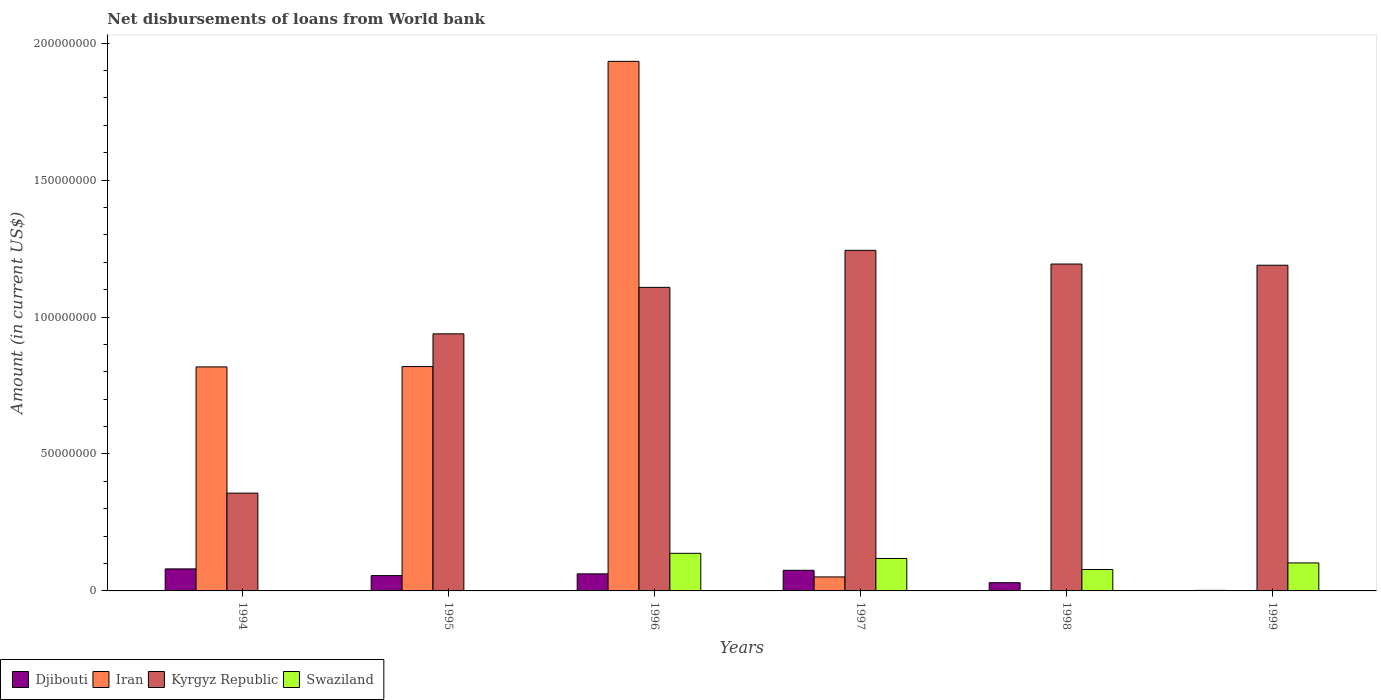How many groups of bars are there?
Ensure brevity in your answer.  6. Are the number of bars on each tick of the X-axis equal?
Your answer should be compact. No. How many bars are there on the 3rd tick from the left?
Provide a short and direct response. 4. What is the label of the 1st group of bars from the left?
Your response must be concise. 1994. What is the amount of loan disbursed from World Bank in Djibouti in 1996?
Your response must be concise. 6.23e+06. Across all years, what is the maximum amount of loan disbursed from World Bank in Swaziland?
Your response must be concise. 1.37e+07. Across all years, what is the minimum amount of loan disbursed from World Bank in Djibouti?
Give a very brief answer. 1.97e+05. In which year was the amount of loan disbursed from World Bank in Kyrgyz Republic maximum?
Provide a short and direct response. 1997. What is the total amount of loan disbursed from World Bank in Kyrgyz Republic in the graph?
Keep it short and to the point. 6.03e+08. What is the difference between the amount of loan disbursed from World Bank in Djibouti in 1995 and that in 1999?
Provide a succinct answer. 5.39e+06. What is the difference between the amount of loan disbursed from World Bank in Iran in 1994 and the amount of loan disbursed from World Bank in Djibouti in 1995?
Provide a short and direct response. 7.62e+07. What is the average amount of loan disbursed from World Bank in Kyrgyz Republic per year?
Keep it short and to the point. 1.01e+08. In the year 1995, what is the difference between the amount of loan disbursed from World Bank in Kyrgyz Republic and amount of loan disbursed from World Bank in Iran?
Ensure brevity in your answer.  1.20e+07. What is the ratio of the amount of loan disbursed from World Bank in Djibouti in 1995 to that in 1997?
Your response must be concise. 0.74. What is the difference between the highest and the second highest amount of loan disbursed from World Bank in Iran?
Your answer should be compact. 1.11e+08. What is the difference between the highest and the lowest amount of loan disbursed from World Bank in Swaziland?
Ensure brevity in your answer.  1.37e+07. In how many years, is the amount of loan disbursed from World Bank in Swaziland greater than the average amount of loan disbursed from World Bank in Swaziland taken over all years?
Keep it short and to the point. 4. Are all the bars in the graph horizontal?
Make the answer very short. No. Does the graph contain any zero values?
Provide a short and direct response. Yes. Where does the legend appear in the graph?
Give a very brief answer. Bottom left. How are the legend labels stacked?
Your answer should be very brief. Horizontal. What is the title of the graph?
Provide a short and direct response. Net disbursements of loans from World bank. Does "Italy" appear as one of the legend labels in the graph?
Give a very brief answer. No. What is the label or title of the X-axis?
Make the answer very short. Years. What is the label or title of the Y-axis?
Offer a terse response. Amount (in current US$). What is the Amount (in current US$) in Djibouti in 1994?
Make the answer very short. 8.04e+06. What is the Amount (in current US$) of Iran in 1994?
Give a very brief answer. 8.18e+07. What is the Amount (in current US$) in Kyrgyz Republic in 1994?
Ensure brevity in your answer.  3.57e+07. What is the Amount (in current US$) in Swaziland in 1994?
Your answer should be compact. 1.38e+05. What is the Amount (in current US$) in Djibouti in 1995?
Provide a short and direct response. 5.59e+06. What is the Amount (in current US$) of Iran in 1995?
Provide a succinct answer. 8.19e+07. What is the Amount (in current US$) in Kyrgyz Republic in 1995?
Offer a very short reply. 9.39e+07. What is the Amount (in current US$) of Swaziland in 1995?
Offer a very short reply. 0. What is the Amount (in current US$) of Djibouti in 1996?
Offer a very short reply. 6.23e+06. What is the Amount (in current US$) in Iran in 1996?
Provide a short and direct response. 1.93e+08. What is the Amount (in current US$) of Kyrgyz Republic in 1996?
Make the answer very short. 1.11e+08. What is the Amount (in current US$) in Swaziland in 1996?
Provide a succinct answer. 1.37e+07. What is the Amount (in current US$) in Djibouti in 1997?
Keep it short and to the point. 7.53e+06. What is the Amount (in current US$) in Iran in 1997?
Keep it short and to the point. 5.11e+06. What is the Amount (in current US$) of Kyrgyz Republic in 1997?
Give a very brief answer. 1.24e+08. What is the Amount (in current US$) in Swaziland in 1997?
Offer a terse response. 1.18e+07. What is the Amount (in current US$) of Djibouti in 1998?
Your answer should be compact. 3.00e+06. What is the Amount (in current US$) of Kyrgyz Republic in 1998?
Your answer should be very brief. 1.19e+08. What is the Amount (in current US$) in Swaziland in 1998?
Keep it short and to the point. 7.82e+06. What is the Amount (in current US$) in Djibouti in 1999?
Keep it short and to the point. 1.97e+05. What is the Amount (in current US$) in Kyrgyz Republic in 1999?
Your response must be concise. 1.19e+08. What is the Amount (in current US$) in Swaziland in 1999?
Keep it short and to the point. 1.02e+07. Across all years, what is the maximum Amount (in current US$) in Djibouti?
Ensure brevity in your answer.  8.04e+06. Across all years, what is the maximum Amount (in current US$) in Iran?
Your answer should be compact. 1.93e+08. Across all years, what is the maximum Amount (in current US$) of Kyrgyz Republic?
Your answer should be compact. 1.24e+08. Across all years, what is the maximum Amount (in current US$) of Swaziland?
Your response must be concise. 1.37e+07. Across all years, what is the minimum Amount (in current US$) of Djibouti?
Offer a very short reply. 1.97e+05. Across all years, what is the minimum Amount (in current US$) of Kyrgyz Republic?
Offer a terse response. 3.57e+07. Across all years, what is the minimum Amount (in current US$) in Swaziland?
Make the answer very short. 0. What is the total Amount (in current US$) in Djibouti in the graph?
Provide a short and direct response. 3.06e+07. What is the total Amount (in current US$) of Iran in the graph?
Your response must be concise. 3.62e+08. What is the total Amount (in current US$) in Kyrgyz Republic in the graph?
Provide a succinct answer. 6.03e+08. What is the total Amount (in current US$) of Swaziland in the graph?
Offer a terse response. 4.38e+07. What is the difference between the Amount (in current US$) of Djibouti in 1994 and that in 1995?
Offer a very short reply. 2.46e+06. What is the difference between the Amount (in current US$) in Iran in 1994 and that in 1995?
Offer a terse response. -1.22e+05. What is the difference between the Amount (in current US$) in Kyrgyz Republic in 1994 and that in 1995?
Provide a succinct answer. -5.82e+07. What is the difference between the Amount (in current US$) in Djibouti in 1994 and that in 1996?
Keep it short and to the point. 1.81e+06. What is the difference between the Amount (in current US$) in Iran in 1994 and that in 1996?
Offer a terse response. -1.12e+08. What is the difference between the Amount (in current US$) in Kyrgyz Republic in 1994 and that in 1996?
Keep it short and to the point. -7.51e+07. What is the difference between the Amount (in current US$) in Swaziland in 1994 and that in 1996?
Ensure brevity in your answer.  -1.36e+07. What is the difference between the Amount (in current US$) of Djibouti in 1994 and that in 1997?
Your answer should be very brief. 5.17e+05. What is the difference between the Amount (in current US$) in Iran in 1994 and that in 1997?
Offer a very short reply. 7.67e+07. What is the difference between the Amount (in current US$) in Kyrgyz Republic in 1994 and that in 1997?
Provide a succinct answer. -8.86e+07. What is the difference between the Amount (in current US$) in Swaziland in 1994 and that in 1997?
Make the answer very short. -1.17e+07. What is the difference between the Amount (in current US$) in Djibouti in 1994 and that in 1998?
Your answer should be very brief. 5.04e+06. What is the difference between the Amount (in current US$) in Kyrgyz Republic in 1994 and that in 1998?
Your answer should be compact. -8.37e+07. What is the difference between the Amount (in current US$) of Swaziland in 1994 and that in 1998?
Make the answer very short. -7.68e+06. What is the difference between the Amount (in current US$) in Djibouti in 1994 and that in 1999?
Your answer should be compact. 7.85e+06. What is the difference between the Amount (in current US$) in Kyrgyz Republic in 1994 and that in 1999?
Your answer should be very brief. -8.32e+07. What is the difference between the Amount (in current US$) in Swaziland in 1994 and that in 1999?
Your answer should be compact. -1.01e+07. What is the difference between the Amount (in current US$) in Djibouti in 1995 and that in 1996?
Your answer should be compact. -6.44e+05. What is the difference between the Amount (in current US$) of Iran in 1995 and that in 1996?
Provide a short and direct response. -1.11e+08. What is the difference between the Amount (in current US$) of Kyrgyz Republic in 1995 and that in 1996?
Ensure brevity in your answer.  -1.70e+07. What is the difference between the Amount (in current US$) in Djibouti in 1995 and that in 1997?
Your answer should be compact. -1.94e+06. What is the difference between the Amount (in current US$) of Iran in 1995 and that in 1997?
Offer a terse response. 7.68e+07. What is the difference between the Amount (in current US$) of Kyrgyz Republic in 1995 and that in 1997?
Provide a succinct answer. -3.05e+07. What is the difference between the Amount (in current US$) of Djibouti in 1995 and that in 1998?
Your answer should be very brief. 2.58e+06. What is the difference between the Amount (in current US$) in Kyrgyz Republic in 1995 and that in 1998?
Your answer should be compact. -2.55e+07. What is the difference between the Amount (in current US$) in Djibouti in 1995 and that in 1999?
Provide a short and direct response. 5.39e+06. What is the difference between the Amount (in current US$) in Kyrgyz Republic in 1995 and that in 1999?
Ensure brevity in your answer.  -2.51e+07. What is the difference between the Amount (in current US$) of Djibouti in 1996 and that in 1997?
Provide a short and direct response. -1.30e+06. What is the difference between the Amount (in current US$) in Iran in 1996 and that in 1997?
Ensure brevity in your answer.  1.88e+08. What is the difference between the Amount (in current US$) of Kyrgyz Republic in 1996 and that in 1997?
Offer a very short reply. -1.35e+07. What is the difference between the Amount (in current US$) in Swaziland in 1996 and that in 1997?
Ensure brevity in your answer.  1.89e+06. What is the difference between the Amount (in current US$) in Djibouti in 1996 and that in 1998?
Your answer should be compact. 3.23e+06. What is the difference between the Amount (in current US$) of Kyrgyz Republic in 1996 and that in 1998?
Provide a succinct answer. -8.51e+06. What is the difference between the Amount (in current US$) of Swaziland in 1996 and that in 1998?
Your answer should be very brief. 5.92e+06. What is the difference between the Amount (in current US$) in Djibouti in 1996 and that in 1999?
Give a very brief answer. 6.03e+06. What is the difference between the Amount (in current US$) in Kyrgyz Republic in 1996 and that in 1999?
Make the answer very short. -8.08e+06. What is the difference between the Amount (in current US$) of Swaziland in 1996 and that in 1999?
Offer a terse response. 3.51e+06. What is the difference between the Amount (in current US$) of Djibouti in 1997 and that in 1998?
Your answer should be compact. 4.52e+06. What is the difference between the Amount (in current US$) of Kyrgyz Republic in 1997 and that in 1998?
Provide a succinct answer. 5.00e+06. What is the difference between the Amount (in current US$) of Swaziland in 1997 and that in 1998?
Your answer should be very brief. 4.03e+06. What is the difference between the Amount (in current US$) in Djibouti in 1997 and that in 1999?
Keep it short and to the point. 7.33e+06. What is the difference between the Amount (in current US$) in Kyrgyz Republic in 1997 and that in 1999?
Provide a short and direct response. 5.43e+06. What is the difference between the Amount (in current US$) in Swaziland in 1997 and that in 1999?
Offer a terse response. 1.62e+06. What is the difference between the Amount (in current US$) of Djibouti in 1998 and that in 1999?
Provide a short and direct response. 2.81e+06. What is the difference between the Amount (in current US$) of Kyrgyz Republic in 1998 and that in 1999?
Your response must be concise. 4.34e+05. What is the difference between the Amount (in current US$) of Swaziland in 1998 and that in 1999?
Provide a succinct answer. -2.41e+06. What is the difference between the Amount (in current US$) in Djibouti in 1994 and the Amount (in current US$) in Iran in 1995?
Your response must be concise. -7.39e+07. What is the difference between the Amount (in current US$) in Djibouti in 1994 and the Amount (in current US$) in Kyrgyz Republic in 1995?
Ensure brevity in your answer.  -8.58e+07. What is the difference between the Amount (in current US$) of Iran in 1994 and the Amount (in current US$) of Kyrgyz Republic in 1995?
Offer a terse response. -1.21e+07. What is the difference between the Amount (in current US$) of Djibouti in 1994 and the Amount (in current US$) of Iran in 1996?
Give a very brief answer. -1.85e+08. What is the difference between the Amount (in current US$) of Djibouti in 1994 and the Amount (in current US$) of Kyrgyz Republic in 1996?
Your response must be concise. -1.03e+08. What is the difference between the Amount (in current US$) in Djibouti in 1994 and the Amount (in current US$) in Swaziland in 1996?
Make the answer very short. -5.69e+06. What is the difference between the Amount (in current US$) of Iran in 1994 and the Amount (in current US$) of Kyrgyz Republic in 1996?
Ensure brevity in your answer.  -2.90e+07. What is the difference between the Amount (in current US$) of Iran in 1994 and the Amount (in current US$) of Swaziland in 1996?
Offer a terse response. 6.81e+07. What is the difference between the Amount (in current US$) in Kyrgyz Republic in 1994 and the Amount (in current US$) in Swaziland in 1996?
Give a very brief answer. 2.20e+07. What is the difference between the Amount (in current US$) in Djibouti in 1994 and the Amount (in current US$) in Iran in 1997?
Your answer should be very brief. 2.94e+06. What is the difference between the Amount (in current US$) in Djibouti in 1994 and the Amount (in current US$) in Kyrgyz Republic in 1997?
Provide a succinct answer. -1.16e+08. What is the difference between the Amount (in current US$) in Djibouti in 1994 and the Amount (in current US$) in Swaziland in 1997?
Provide a succinct answer. -3.80e+06. What is the difference between the Amount (in current US$) of Iran in 1994 and the Amount (in current US$) of Kyrgyz Republic in 1997?
Your answer should be compact. -4.26e+07. What is the difference between the Amount (in current US$) of Iran in 1994 and the Amount (in current US$) of Swaziland in 1997?
Offer a very short reply. 7.00e+07. What is the difference between the Amount (in current US$) in Kyrgyz Republic in 1994 and the Amount (in current US$) in Swaziland in 1997?
Provide a succinct answer. 2.39e+07. What is the difference between the Amount (in current US$) in Djibouti in 1994 and the Amount (in current US$) in Kyrgyz Republic in 1998?
Keep it short and to the point. -1.11e+08. What is the difference between the Amount (in current US$) of Djibouti in 1994 and the Amount (in current US$) of Swaziland in 1998?
Your answer should be very brief. 2.28e+05. What is the difference between the Amount (in current US$) of Iran in 1994 and the Amount (in current US$) of Kyrgyz Republic in 1998?
Ensure brevity in your answer.  -3.76e+07. What is the difference between the Amount (in current US$) of Iran in 1994 and the Amount (in current US$) of Swaziland in 1998?
Make the answer very short. 7.40e+07. What is the difference between the Amount (in current US$) of Kyrgyz Republic in 1994 and the Amount (in current US$) of Swaziland in 1998?
Ensure brevity in your answer.  2.79e+07. What is the difference between the Amount (in current US$) of Djibouti in 1994 and the Amount (in current US$) of Kyrgyz Republic in 1999?
Your response must be concise. -1.11e+08. What is the difference between the Amount (in current US$) in Djibouti in 1994 and the Amount (in current US$) in Swaziland in 1999?
Ensure brevity in your answer.  -2.18e+06. What is the difference between the Amount (in current US$) of Iran in 1994 and the Amount (in current US$) of Kyrgyz Republic in 1999?
Ensure brevity in your answer.  -3.71e+07. What is the difference between the Amount (in current US$) in Iran in 1994 and the Amount (in current US$) in Swaziland in 1999?
Make the answer very short. 7.16e+07. What is the difference between the Amount (in current US$) of Kyrgyz Republic in 1994 and the Amount (in current US$) of Swaziland in 1999?
Provide a short and direct response. 2.55e+07. What is the difference between the Amount (in current US$) of Djibouti in 1995 and the Amount (in current US$) of Iran in 1996?
Give a very brief answer. -1.88e+08. What is the difference between the Amount (in current US$) of Djibouti in 1995 and the Amount (in current US$) of Kyrgyz Republic in 1996?
Your response must be concise. -1.05e+08. What is the difference between the Amount (in current US$) in Djibouti in 1995 and the Amount (in current US$) in Swaziland in 1996?
Give a very brief answer. -8.14e+06. What is the difference between the Amount (in current US$) in Iran in 1995 and the Amount (in current US$) in Kyrgyz Republic in 1996?
Provide a short and direct response. -2.89e+07. What is the difference between the Amount (in current US$) of Iran in 1995 and the Amount (in current US$) of Swaziland in 1996?
Provide a succinct answer. 6.82e+07. What is the difference between the Amount (in current US$) in Kyrgyz Republic in 1995 and the Amount (in current US$) in Swaziland in 1996?
Offer a terse response. 8.01e+07. What is the difference between the Amount (in current US$) of Djibouti in 1995 and the Amount (in current US$) of Iran in 1997?
Provide a succinct answer. 4.79e+05. What is the difference between the Amount (in current US$) in Djibouti in 1995 and the Amount (in current US$) in Kyrgyz Republic in 1997?
Keep it short and to the point. -1.19e+08. What is the difference between the Amount (in current US$) of Djibouti in 1995 and the Amount (in current US$) of Swaziland in 1997?
Provide a short and direct response. -6.26e+06. What is the difference between the Amount (in current US$) in Iran in 1995 and the Amount (in current US$) in Kyrgyz Republic in 1997?
Your response must be concise. -4.24e+07. What is the difference between the Amount (in current US$) of Iran in 1995 and the Amount (in current US$) of Swaziland in 1997?
Offer a terse response. 7.01e+07. What is the difference between the Amount (in current US$) of Kyrgyz Republic in 1995 and the Amount (in current US$) of Swaziland in 1997?
Provide a short and direct response. 8.20e+07. What is the difference between the Amount (in current US$) in Djibouti in 1995 and the Amount (in current US$) in Kyrgyz Republic in 1998?
Give a very brief answer. -1.14e+08. What is the difference between the Amount (in current US$) in Djibouti in 1995 and the Amount (in current US$) in Swaziland in 1998?
Keep it short and to the point. -2.23e+06. What is the difference between the Amount (in current US$) of Iran in 1995 and the Amount (in current US$) of Kyrgyz Republic in 1998?
Ensure brevity in your answer.  -3.74e+07. What is the difference between the Amount (in current US$) in Iran in 1995 and the Amount (in current US$) in Swaziland in 1998?
Offer a terse response. 7.41e+07. What is the difference between the Amount (in current US$) of Kyrgyz Republic in 1995 and the Amount (in current US$) of Swaziland in 1998?
Offer a terse response. 8.61e+07. What is the difference between the Amount (in current US$) in Djibouti in 1995 and the Amount (in current US$) in Kyrgyz Republic in 1999?
Your answer should be very brief. -1.13e+08. What is the difference between the Amount (in current US$) in Djibouti in 1995 and the Amount (in current US$) in Swaziland in 1999?
Ensure brevity in your answer.  -4.64e+06. What is the difference between the Amount (in current US$) in Iran in 1995 and the Amount (in current US$) in Kyrgyz Republic in 1999?
Offer a terse response. -3.70e+07. What is the difference between the Amount (in current US$) of Iran in 1995 and the Amount (in current US$) of Swaziland in 1999?
Your answer should be compact. 7.17e+07. What is the difference between the Amount (in current US$) in Kyrgyz Republic in 1995 and the Amount (in current US$) in Swaziland in 1999?
Offer a very short reply. 8.36e+07. What is the difference between the Amount (in current US$) in Djibouti in 1996 and the Amount (in current US$) in Iran in 1997?
Provide a short and direct response. 1.12e+06. What is the difference between the Amount (in current US$) of Djibouti in 1996 and the Amount (in current US$) of Kyrgyz Republic in 1997?
Your answer should be very brief. -1.18e+08. What is the difference between the Amount (in current US$) in Djibouti in 1996 and the Amount (in current US$) in Swaziland in 1997?
Offer a very short reply. -5.61e+06. What is the difference between the Amount (in current US$) of Iran in 1996 and the Amount (in current US$) of Kyrgyz Republic in 1997?
Provide a short and direct response. 6.90e+07. What is the difference between the Amount (in current US$) in Iran in 1996 and the Amount (in current US$) in Swaziland in 1997?
Your answer should be very brief. 1.82e+08. What is the difference between the Amount (in current US$) of Kyrgyz Republic in 1996 and the Amount (in current US$) of Swaziland in 1997?
Make the answer very short. 9.90e+07. What is the difference between the Amount (in current US$) in Djibouti in 1996 and the Amount (in current US$) in Kyrgyz Republic in 1998?
Provide a short and direct response. -1.13e+08. What is the difference between the Amount (in current US$) in Djibouti in 1996 and the Amount (in current US$) in Swaziland in 1998?
Your response must be concise. -1.58e+06. What is the difference between the Amount (in current US$) in Iran in 1996 and the Amount (in current US$) in Kyrgyz Republic in 1998?
Your answer should be very brief. 7.40e+07. What is the difference between the Amount (in current US$) of Iran in 1996 and the Amount (in current US$) of Swaziland in 1998?
Your answer should be very brief. 1.86e+08. What is the difference between the Amount (in current US$) in Kyrgyz Republic in 1996 and the Amount (in current US$) in Swaziland in 1998?
Provide a succinct answer. 1.03e+08. What is the difference between the Amount (in current US$) of Djibouti in 1996 and the Amount (in current US$) of Kyrgyz Republic in 1999?
Provide a succinct answer. -1.13e+08. What is the difference between the Amount (in current US$) of Djibouti in 1996 and the Amount (in current US$) of Swaziland in 1999?
Your response must be concise. -3.99e+06. What is the difference between the Amount (in current US$) in Iran in 1996 and the Amount (in current US$) in Kyrgyz Republic in 1999?
Offer a very short reply. 7.44e+07. What is the difference between the Amount (in current US$) of Iran in 1996 and the Amount (in current US$) of Swaziland in 1999?
Keep it short and to the point. 1.83e+08. What is the difference between the Amount (in current US$) in Kyrgyz Republic in 1996 and the Amount (in current US$) in Swaziland in 1999?
Offer a terse response. 1.01e+08. What is the difference between the Amount (in current US$) in Djibouti in 1997 and the Amount (in current US$) in Kyrgyz Republic in 1998?
Give a very brief answer. -1.12e+08. What is the difference between the Amount (in current US$) of Djibouti in 1997 and the Amount (in current US$) of Swaziland in 1998?
Offer a very short reply. -2.89e+05. What is the difference between the Amount (in current US$) in Iran in 1997 and the Amount (in current US$) in Kyrgyz Republic in 1998?
Keep it short and to the point. -1.14e+08. What is the difference between the Amount (in current US$) in Iran in 1997 and the Amount (in current US$) in Swaziland in 1998?
Offer a very short reply. -2.71e+06. What is the difference between the Amount (in current US$) of Kyrgyz Republic in 1997 and the Amount (in current US$) of Swaziland in 1998?
Offer a terse response. 1.17e+08. What is the difference between the Amount (in current US$) in Djibouti in 1997 and the Amount (in current US$) in Kyrgyz Republic in 1999?
Offer a terse response. -1.11e+08. What is the difference between the Amount (in current US$) in Djibouti in 1997 and the Amount (in current US$) in Swaziland in 1999?
Provide a short and direct response. -2.70e+06. What is the difference between the Amount (in current US$) of Iran in 1997 and the Amount (in current US$) of Kyrgyz Republic in 1999?
Your answer should be very brief. -1.14e+08. What is the difference between the Amount (in current US$) of Iran in 1997 and the Amount (in current US$) of Swaziland in 1999?
Provide a succinct answer. -5.12e+06. What is the difference between the Amount (in current US$) in Kyrgyz Republic in 1997 and the Amount (in current US$) in Swaziland in 1999?
Keep it short and to the point. 1.14e+08. What is the difference between the Amount (in current US$) of Djibouti in 1998 and the Amount (in current US$) of Kyrgyz Republic in 1999?
Your response must be concise. -1.16e+08. What is the difference between the Amount (in current US$) of Djibouti in 1998 and the Amount (in current US$) of Swaziland in 1999?
Provide a succinct answer. -7.22e+06. What is the difference between the Amount (in current US$) of Kyrgyz Republic in 1998 and the Amount (in current US$) of Swaziland in 1999?
Offer a terse response. 1.09e+08. What is the average Amount (in current US$) in Djibouti per year?
Your answer should be compact. 5.10e+06. What is the average Amount (in current US$) of Iran per year?
Provide a short and direct response. 6.04e+07. What is the average Amount (in current US$) in Kyrgyz Republic per year?
Keep it short and to the point. 1.01e+08. What is the average Amount (in current US$) of Swaziland per year?
Your answer should be compact. 7.29e+06. In the year 1994, what is the difference between the Amount (in current US$) of Djibouti and Amount (in current US$) of Iran?
Your response must be concise. -7.38e+07. In the year 1994, what is the difference between the Amount (in current US$) in Djibouti and Amount (in current US$) in Kyrgyz Republic?
Your response must be concise. -2.77e+07. In the year 1994, what is the difference between the Amount (in current US$) of Djibouti and Amount (in current US$) of Swaziland?
Ensure brevity in your answer.  7.91e+06. In the year 1994, what is the difference between the Amount (in current US$) of Iran and Amount (in current US$) of Kyrgyz Republic?
Your answer should be compact. 4.61e+07. In the year 1994, what is the difference between the Amount (in current US$) in Iran and Amount (in current US$) in Swaziland?
Your answer should be very brief. 8.17e+07. In the year 1994, what is the difference between the Amount (in current US$) in Kyrgyz Republic and Amount (in current US$) in Swaziland?
Give a very brief answer. 3.56e+07. In the year 1995, what is the difference between the Amount (in current US$) of Djibouti and Amount (in current US$) of Iran?
Make the answer very short. -7.63e+07. In the year 1995, what is the difference between the Amount (in current US$) in Djibouti and Amount (in current US$) in Kyrgyz Republic?
Make the answer very short. -8.83e+07. In the year 1995, what is the difference between the Amount (in current US$) in Iran and Amount (in current US$) in Kyrgyz Republic?
Give a very brief answer. -1.20e+07. In the year 1996, what is the difference between the Amount (in current US$) in Djibouti and Amount (in current US$) in Iran?
Give a very brief answer. -1.87e+08. In the year 1996, what is the difference between the Amount (in current US$) in Djibouti and Amount (in current US$) in Kyrgyz Republic?
Keep it short and to the point. -1.05e+08. In the year 1996, what is the difference between the Amount (in current US$) in Djibouti and Amount (in current US$) in Swaziland?
Give a very brief answer. -7.50e+06. In the year 1996, what is the difference between the Amount (in current US$) in Iran and Amount (in current US$) in Kyrgyz Republic?
Your answer should be very brief. 8.25e+07. In the year 1996, what is the difference between the Amount (in current US$) of Iran and Amount (in current US$) of Swaziland?
Keep it short and to the point. 1.80e+08. In the year 1996, what is the difference between the Amount (in current US$) of Kyrgyz Republic and Amount (in current US$) of Swaziland?
Your answer should be compact. 9.71e+07. In the year 1997, what is the difference between the Amount (in current US$) of Djibouti and Amount (in current US$) of Iran?
Your answer should be very brief. 2.42e+06. In the year 1997, what is the difference between the Amount (in current US$) in Djibouti and Amount (in current US$) in Kyrgyz Republic?
Keep it short and to the point. -1.17e+08. In the year 1997, what is the difference between the Amount (in current US$) in Djibouti and Amount (in current US$) in Swaziland?
Offer a terse response. -4.32e+06. In the year 1997, what is the difference between the Amount (in current US$) of Iran and Amount (in current US$) of Kyrgyz Republic?
Ensure brevity in your answer.  -1.19e+08. In the year 1997, what is the difference between the Amount (in current US$) in Iran and Amount (in current US$) in Swaziland?
Ensure brevity in your answer.  -6.74e+06. In the year 1997, what is the difference between the Amount (in current US$) in Kyrgyz Republic and Amount (in current US$) in Swaziland?
Make the answer very short. 1.13e+08. In the year 1998, what is the difference between the Amount (in current US$) of Djibouti and Amount (in current US$) of Kyrgyz Republic?
Offer a very short reply. -1.16e+08. In the year 1998, what is the difference between the Amount (in current US$) in Djibouti and Amount (in current US$) in Swaziland?
Offer a very short reply. -4.81e+06. In the year 1998, what is the difference between the Amount (in current US$) in Kyrgyz Republic and Amount (in current US$) in Swaziland?
Ensure brevity in your answer.  1.12e+08. In the year 1999, what is the difference between the Amount (in current US$) of Djibouti and Amount (in current US$) of Kyrgyz Republic?
Your answer should be very brief. -1.19e+08. In the year 1999, what is the difference between the Amount (in current US$) of Djibouti and Amount (in current US$) of Swaziland?
Offer a very short reply. -1.00e+07. In the year 1999, what is the difference between the Amount (in current US$) of Kyrgyz Republic and Amount (in current US$) of Swaziland?
Keep it short and to the point. 1.09e+08. What is the ratio of the Amount (in current US$) in Djibouti in 1994 to that in 1995?
Your answer should be very brief. 1.44. What is the ratio of the Amount (in current US$) in Kyrgyz Republic in 1994 to that in 1995?
Provide a short and direct response. 0.38. What is the ratio of the Amount (in current US$) in Djibouti in 1994 to that in 1996?
Keep it short and to the point. 1.29. What is the ratio of the Amount (in current US$) in Iran in 1994 to that in 1996?
Make the answer very short. 0.42. What is the ratio of the Amount (in current US$) of Kyrgyz Republic in 1994 to that in 1996?
Keep it short and to the point. 0.32. What is the ratio of the Amount (in current US$) of Swaziland in 1994 to that in 1996?
Your response must be concise. 0.01. What is the ratio of the Amount (in current US$) of Djibouti in 1994 to that in 1997?
Your answer should be very brief. 1.07. What is the ratio of the Amount (in current US$) in Iran in 1994 to that in 1997?
Offer a very short reply. 16.01. What is the ratio of the Amount (in current US$) in Kyrgyz Republic in 1994 to that in 1997?
Your response must be concise. 0.29. What is the ratio of the Amount (in current US$) in Swaziland in 1994 to that in 1997?
Give a very brief answer. 0.01. What is the ratio of the Amount (in current US$) of Djibouti in 1994 to that in 1998?
Keep it short and to the point. 2.68. What is the ratio of the Amount (in current US$) in Kyrgyz Republic in 1994 to that in 1998?
Your answer should be compact. 0.3. What is the ratio of the Amount (in current US$) of Swaziland in 1994 to that in 1998?
Offer a very short reply. 0.02. What is the ratio of the Amount (in current US$) in Djibouti in 1994 to that in 1999?
Ensure brevity in your answer.  40.83. What is the ratio of the Amount (in current US$) in Kyrgyz Republic in 1994 to that in 1999?
Your answer should be very brief. 0.3. What is the ratio of the Amount (in current US$) of Swaziland in 1994 to that in 1999?
Provide a succinct answer. 0.01. What is the ratio of the Amount (in current US$) of Djibouti in 1995 to that in 1996?
Give a very brief answer. 0.9. What is the ratio of the Amount (in current US$) of Iran in 1995 to that in 1996?
Provide a short and direct response. 0.42. What is the ratio of the Amount (in current US$) of Kyrgyz Republic in 1995 to that in 1996?
Your response must be concise. 0.85. What is the ratio of the Amount (in current US$) of Djibouti in 1995 to that in 1997?
Offer a very short reply. 0.74. What is the ratio of the Amount (in current US$) in Iran in 1995 to that in 1997?
Give a very brief answer. 16.04. What is the ratio of the Amount (in current US$) of Kyrgyz Republic in 1995 to that in 1997?
Your response must be concise. 0.75. What is the ratio of the Amount (in current US$) in Djibouti in 1995 to that in 1998?
Make the answer very short. 1.86. What is the ratio of the Amount (in current US$) in Kyrgyz Republic in 1995 to that in 1998?
Provide a succinct answer. 0.79. What is the ratio of the Amount (in current US$) in Djibouti in 1995 to that in 1999?
Offer a terse response. 28.36. What is the ratio of the Amount (in current US$) in Kyrgyz Republic in 1995 to that in 1999?
Your response must be concise. 0.79. What is the ratio of the Amount (in current US$) in Djibouti in 1996 to that in 1997?
Provide a short and direct response. 0.83. What is the ratio of the Amount (in current US$) of Iran in 1996 to that in 1997?
Offer a terse response. 37.86. What is the ratio of the Amount (in current US$) in Kyrgyz Republic in 1996 to that in 1997?
Ensure brevity in your answer.  0.89. What is the ratio of the Amount (in current US$) of Swaziland in 1996 to that in 1997?
Offer a terse response. 1.16. What is the ratio of the Amount (in current US$) in Djibouti in 1996 to that in 1998?
Your response must be concise. 2.07. What is the ratio of the Amount (in current US$) of Kyrgyz Republic in 1996 to that in 1998?
Offer a very short reply. 0.93. What is the ratio of the Amount (in current US$) of Swaziland in 1996 to that in 1998?
Your answer should be very brief. 1.76. What is the ratio of the Amount (in current US$) in Djibouti in 1996 to that in 1999?
Give a very brief answer. 31.63. What is the ratio of the Amount (in current US$) of Kyrgyz Republic in 1996 to that in 1999?
Keep it short and to the point. 0.93. What is the ratio of the Amount (in current US$) of Swaziland in 1996 to that in 1999?
Make the answer very short. 1.34. What is the ratio of the Amount (in current US$) of Djibouti in 1997 to that in 1998?
Your answer should be compact. 2.5. What is the ratio of the Amount (in current US$) in Kyrgyz Republic in 1997 to that in 1998?
Your response must be concise. 1.04. What is the ratio of the Amount (in current US$) of Swaziland in 1997 to that in 1998?
Make the answer very short. 1.52. What is the ratio of the Amount (in current US$) in Djibouti in 1997 to that in 1999?
Ensure brevity in your answer.  38.21. What is the ratio of the Amount (in current US$) of Kyrgyz Republic in 1997 to that in 1999?
Offer a terse response. 1.05. What is the ratio of the Amount (in current US$) in Swaziland in 1997 to that in 1999?
Offer a terse response. 1.16. What is the ratio of the Amount (in current US$) of Djibouti in 1998 to that in 1999?
Ensure brevity in your answer.  15.25. What is the ratio of the Amount (in current US$) in Swaziland in 1998 to that in 1999?
Your answer should be compact. 0.76. What is the difference between the highest and the second highest Amount (in current US$) in Djibouti?
Your response must be concise. 5.17e+05. What is the difference between the highest and the second highest Amount (in current US$) of Iran?
Your answer should be very brief. 1.11e+08. What is the difference between the highest and the second highest Amount (in current US$) in Kyrgyz Republic?
Provide a succinct answer. 5.00e+06. What is the difference between the highest and the second highest Amount (in current US$) in Swaziland?
Make the answer very short. 1.89e+06. What is the difference between the highest and the lowest Amount (in current US$) of Djibouti?
Offer a very short reply. 7.85e+06. What is the difference between the highest and the lowest Amount (in current US$) in Iran?
Provide a short and direct response. 1.93e+08. What is the difference between the highest and the lowest Amount (in current US$) of Kyrgyz Republic?
Keep it short and to the point. 8.86e+07. What is the difference between the highest and the lowest Amount (in current US$) in Swaziland?
Provide a short and direct response. 1.37e+07. 